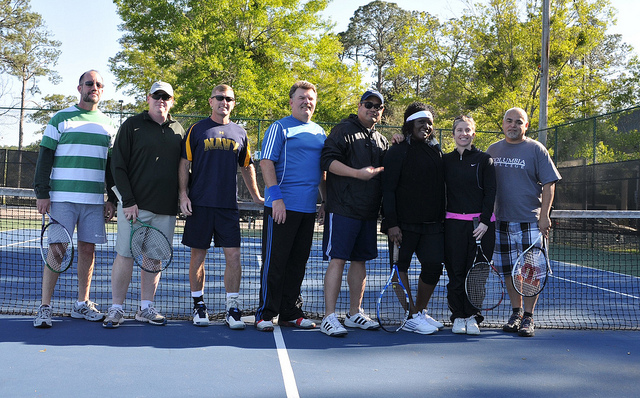Identify and read out the text in this image. NAVY 